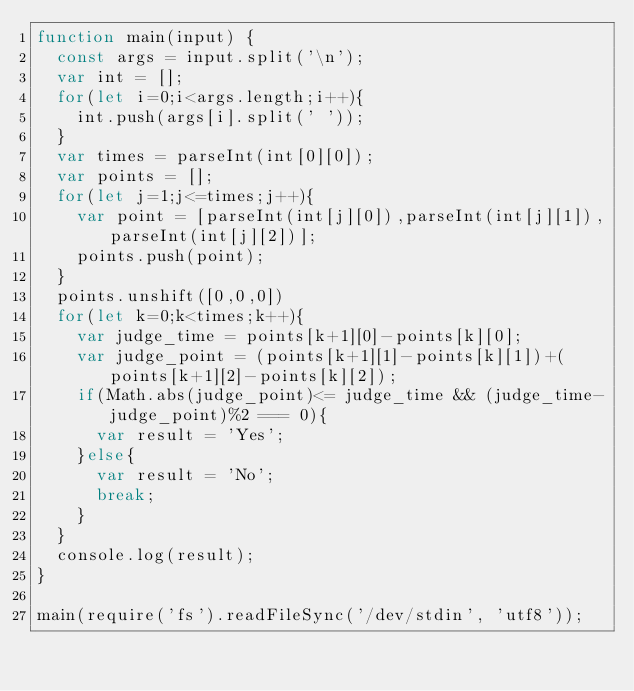Convert code to text. <code><loc_0><loc_0><loc_500><loc_500><_JavaScript_>function main(input) {
  const args = input.split('\n');
  var int = [];
  for(let i=0;i<args.length;i++){
    int.push(args[i].split(' '));
  }
  var times = parseInt(int[0][0]);
  var points = [];
  for(let j=1;j<=times;j++){
    var point = [parseInt(int[j][0]),parseInt(int[j][1]),parseInt(int[j][2])];
    points.push(point);
  }
  points.unshift([0,0,0])
  for(let k=0;k<times;k++){
    var judge_time = points[k+1][0]-points[k][0];
    var judge_point = (points[k+1][1]-points[k][1])+(points[k+1][2]-points[k][2]);
    if(Math.abs(judge_point)<= judge_time && (judge_time-judge_point)%2 === 0){
      var result = 'Yes';
    }else{
      var result = 'No';
      break;
    }
  }
  console.log(result);
}

main(require('fs').readFileSync('/dev/stdin', 'utf8'));</code> 